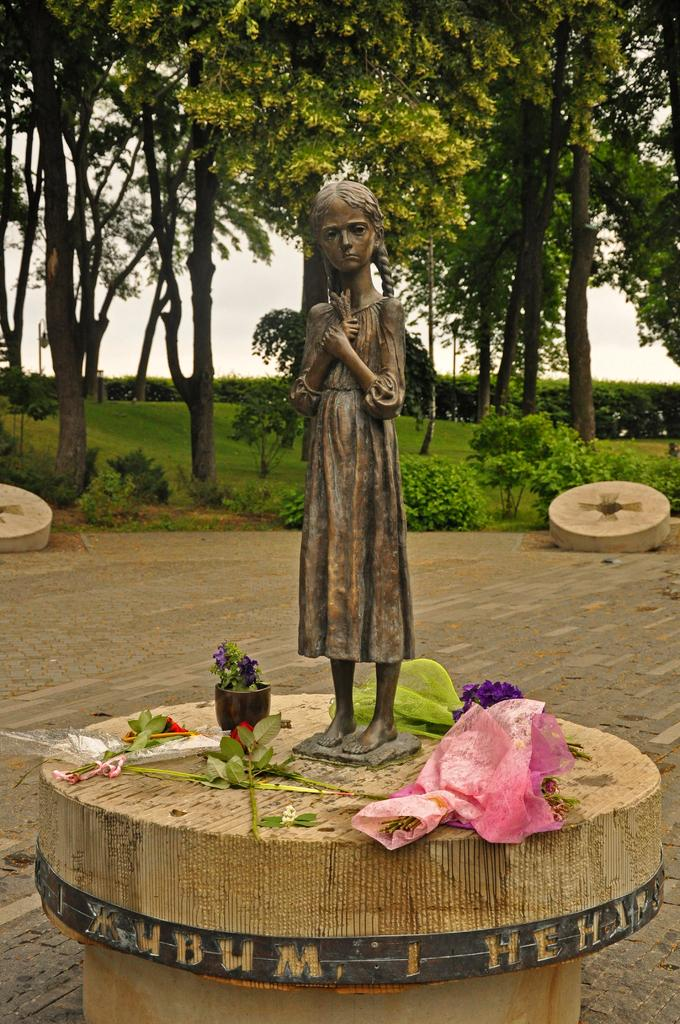What is the main subject in the middle of the image? There is a statue in the middle of the image. What type of vegetation can be seen in the image? There are leaves, plants, and flowers in the image. Where are the plants located in relation to the statue? There are plants behind the statue. What is visible behind the plants? There are trees behind the plants. What is visible in the background of the image? The sky is visible behind the trees. How many grapes are hanging from the statue in the image? There are no grapes present in the image. Can you see any sheep grazing in the background of the image? There are no sheep visible in the image. 